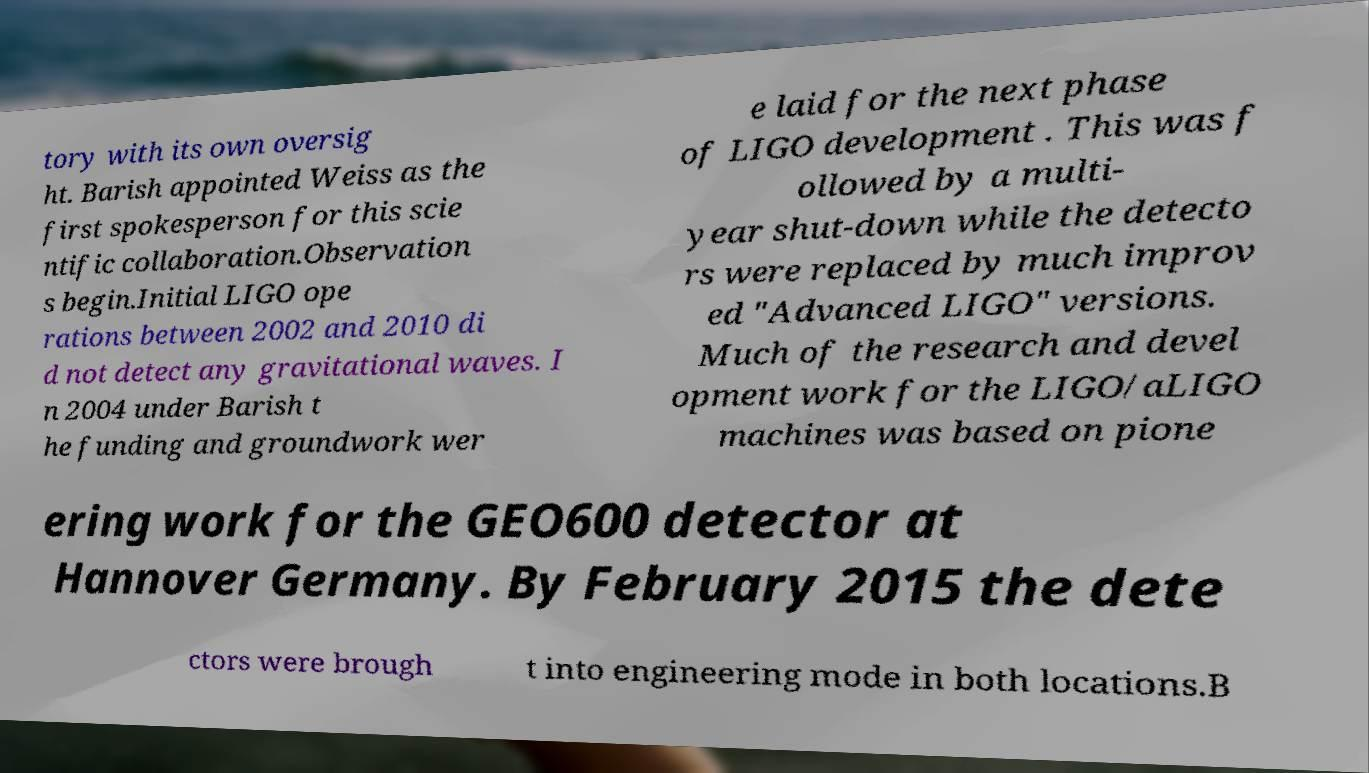Please read and relay the text visible in this image. What does it say? tory with its own oversig ht. Barish appointed Weiss as the first spokesperson for this scie ntific collaboration.Observation s begin.Initial LIGO ope rations between 2002 and 2010 di d not detect any gravitational waves. I n 2004 under Barish t he funding and groundwork wer e laid for the next phase of LIGO development . This was f ollowed by a multi- year shut-down while the detecto rs were replaced by much improv ed "Advanced LIGO" versions. Much of the research and devel opment work for the LIGO/aLIGO machines was based on pione ering work for the GEO600 detector at Hannover Germany. By February 2015 the dete ctors were brough t into engineering mode in both locations.B 